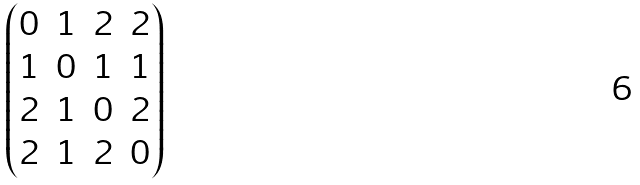Convert formula to latex. <formula><loc_0><loc_0><loc_500><loc_500>\begin{pmatrix} 0 & 1 & 2 & 2 \\ 1 & 0 & 1 & 1 \\ 2 & 1 & 0 & 2 \\ 2 & 1 & 2 & 0 \\ \end{pmatrix}</formula> 